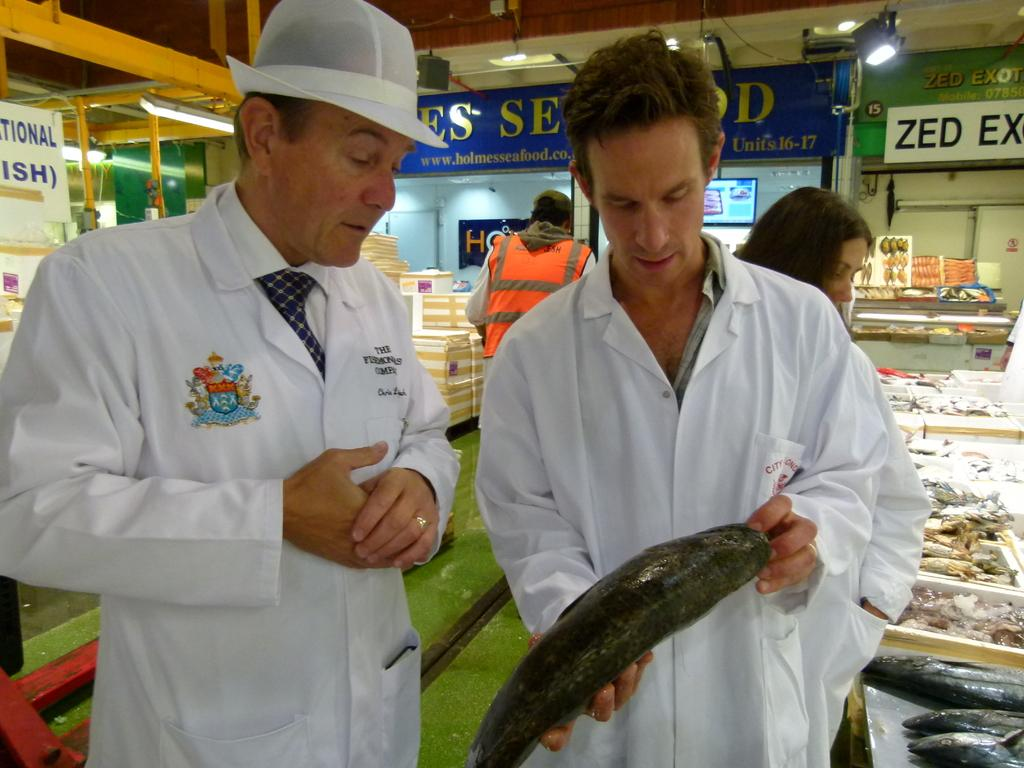<image>
Write a terse but informative summary of the picture. A zed ex sign rests behind the men at a fish market 